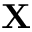<formula> <loc_0><loc_0><loc_500><loc_500>X</formula> 